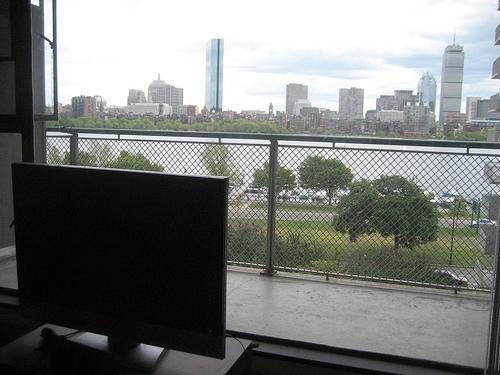How many people are visible in this picture?
Give a very brief answer. 0. How many poles of the fence are in the image?
Give a very brief answer. 2. 